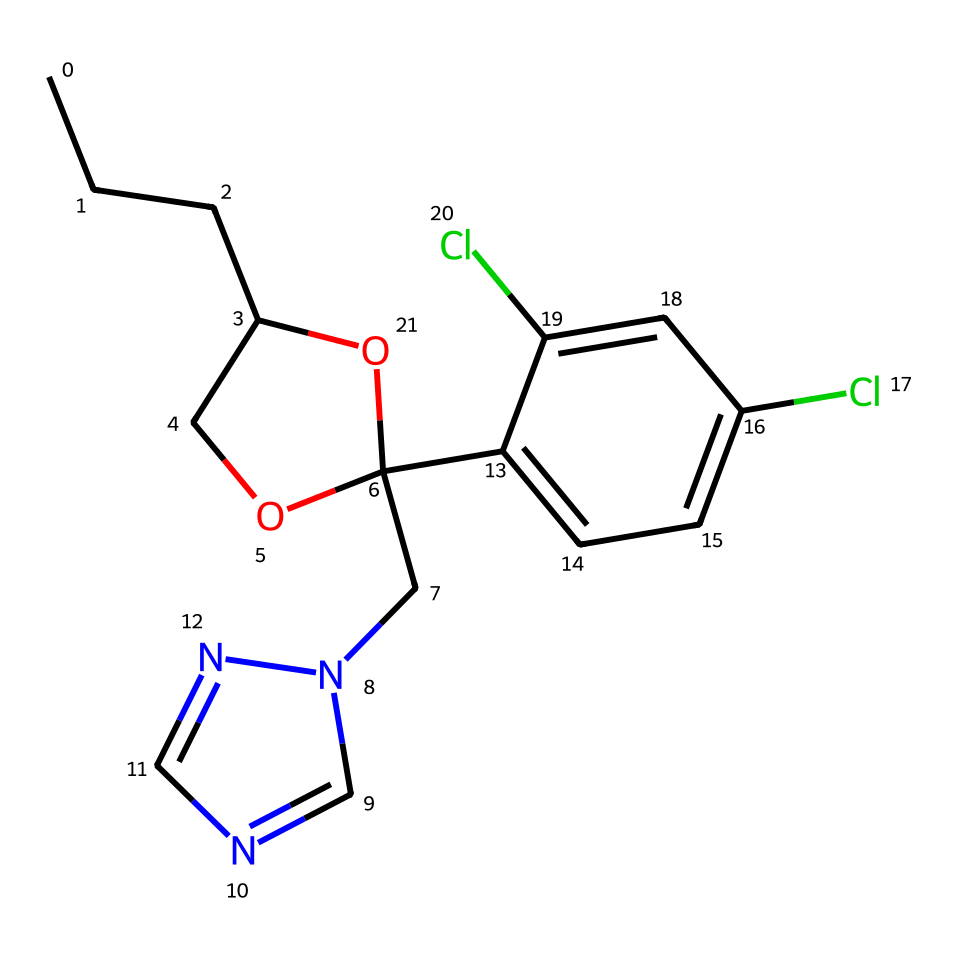What is the IUPAC name of this fungicide? The IUPAC name can be derived from the SMILES representation. Analyzing the structure indicates it has a specific arrangement of carbon, nitrogen, and oxygen atoms, confirming it as propiconazole.
Answer: propiconazole How many carbon atoms does this compound contain? Counting the carbon atoms in the SMILES representation reveals a total of 18 carbon atoms present in the chemical structure.
Answer: 18 What type of functional group is present in this chemical? The chemical structure includes a hydroxyl group (-OH) indicated by 'O1', showing that propiconazole contains an alcohol functional group.
Answer: alcohol Does this chemical contain chlorine atoms? Upon examining the structure, there are two chlorinated benzene rings evident from the 'Cl' symbols included in the SMILES notation, confirming the presence of chlorine atoms.
Answer: yes What is the number of nitrogen atoms in this chemical? By analyzing the SMILES, the indication of 'n' in 'Cn2cncn2' signifies that there are 4 nitrogen atoms present in the structure of propiconazole.
Answer: 4 What structural feature contributes to propiconazole being classified as a systemic fungicide? The presence of multiple ring structures and a side chain with N atoms aids in its efficacy across plant systems, indicating its systemic availability in controlling fungal infections.
Answer: ring structures How does the presence of the ether group influence the behavior of this fungicide? The ether group, represented in the structure by 'C1COC', contributes to the solubility of propiconazole, allowing it to be absorbed by plant tissues more easily, enhancing its fungicidal properties.
Answer: increases solubility 